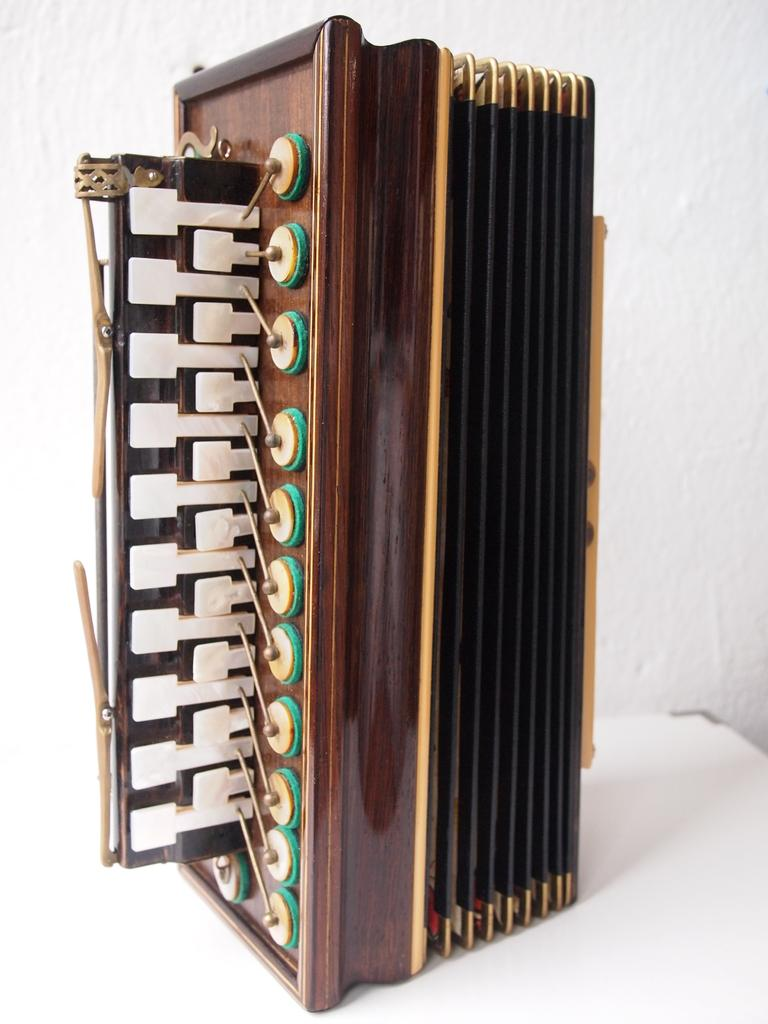What object in the image is used for creating music? There is a musical instrument in the image. Where is the musical instrument placed? The musical instrument is on a platform. What can be seen in the background of the image? There is a wall in the background of the image. How many bushes are visible in the image? There are no bushes present in the image. What type of snakes can be seen slithering on the wall in the image? There are no snakes visible in the image; it only features a musical instrument on a platform with a wall in the background. 